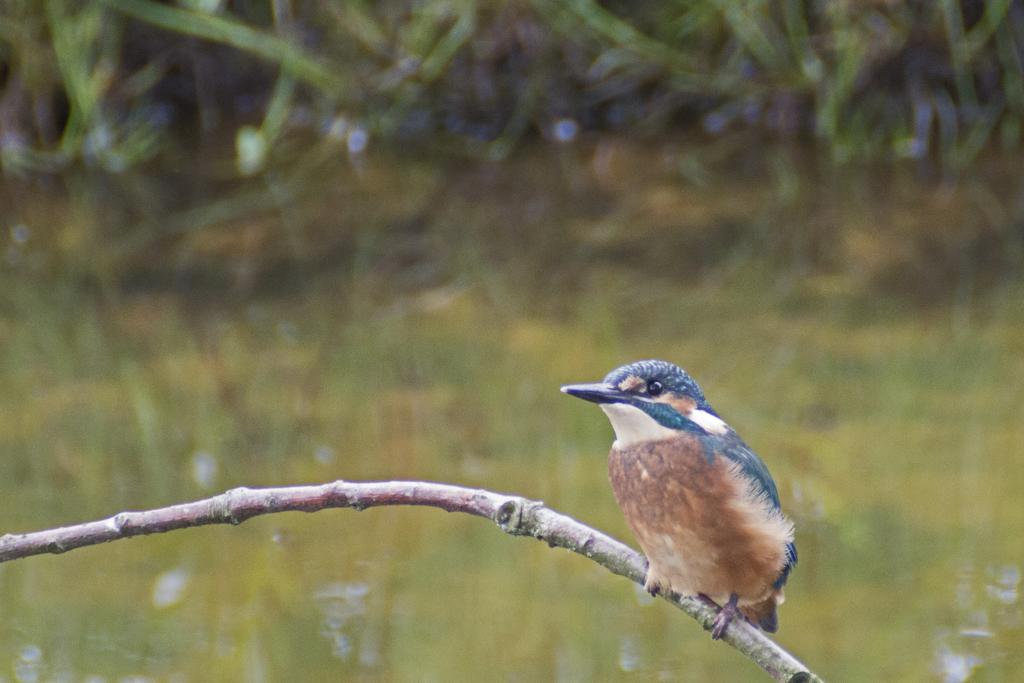What type of animal is in the image? There is a bird in the image. Where is the bird located? The bird is on a stem. What can be seen in the background of the image? There are trees in the background of the image. What type of trouble is the bird causing on the sidewalk in the image? There is no sidewalk present in the image, and the bird is not causing any trouble. 